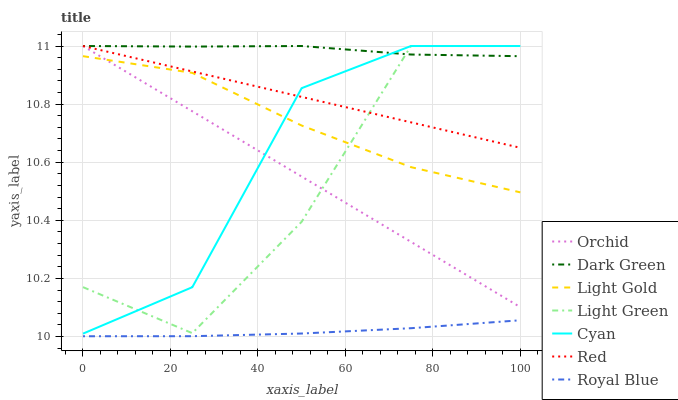Does Royal Blue have the minimum area under the curve?
Answer yes or no. Yes. Does Dark Green have the maximum area under the curve?
Answer yes or no. Yes. Does Light Green have the minimum area under the curve?
Answer yes or no. No. Does Light Green have the maximum area under the curve?
Answer yes or no. No. Is Orchid the smoothest?
Answer yes or no. Yes. Is Light Green the roughest?
Answer yes or no. Yes. Is Cyan the smoothest?
Answer yes or no. No. Is Cyan the roughest?
Answer yes or no. No. Does Royal Blue have the lowest value?
Answer yes or no. Yes. Does Light Green have the lowest value?
Answer yes or no. No. Does Dark Green have the highest value?
Answer yes or no. Yes. Does Light Gold have the highest value?
Answer yes or no. No. Is Royal Blue less than Light Green?
Answer yes or no. Yes. Is Cyan greater than Royal Blue?
Answer yes or no. Yes. Does Dark Green intersect Orchid?
Answer yes or no. Yes. Is Dark Green less than Orchid?
Answer yes or no. No. Is Dark Green greater than Orchid?
Answer yes or no. No. Does Royal Blue intersect Light Green?
Answer yes or no. No. 